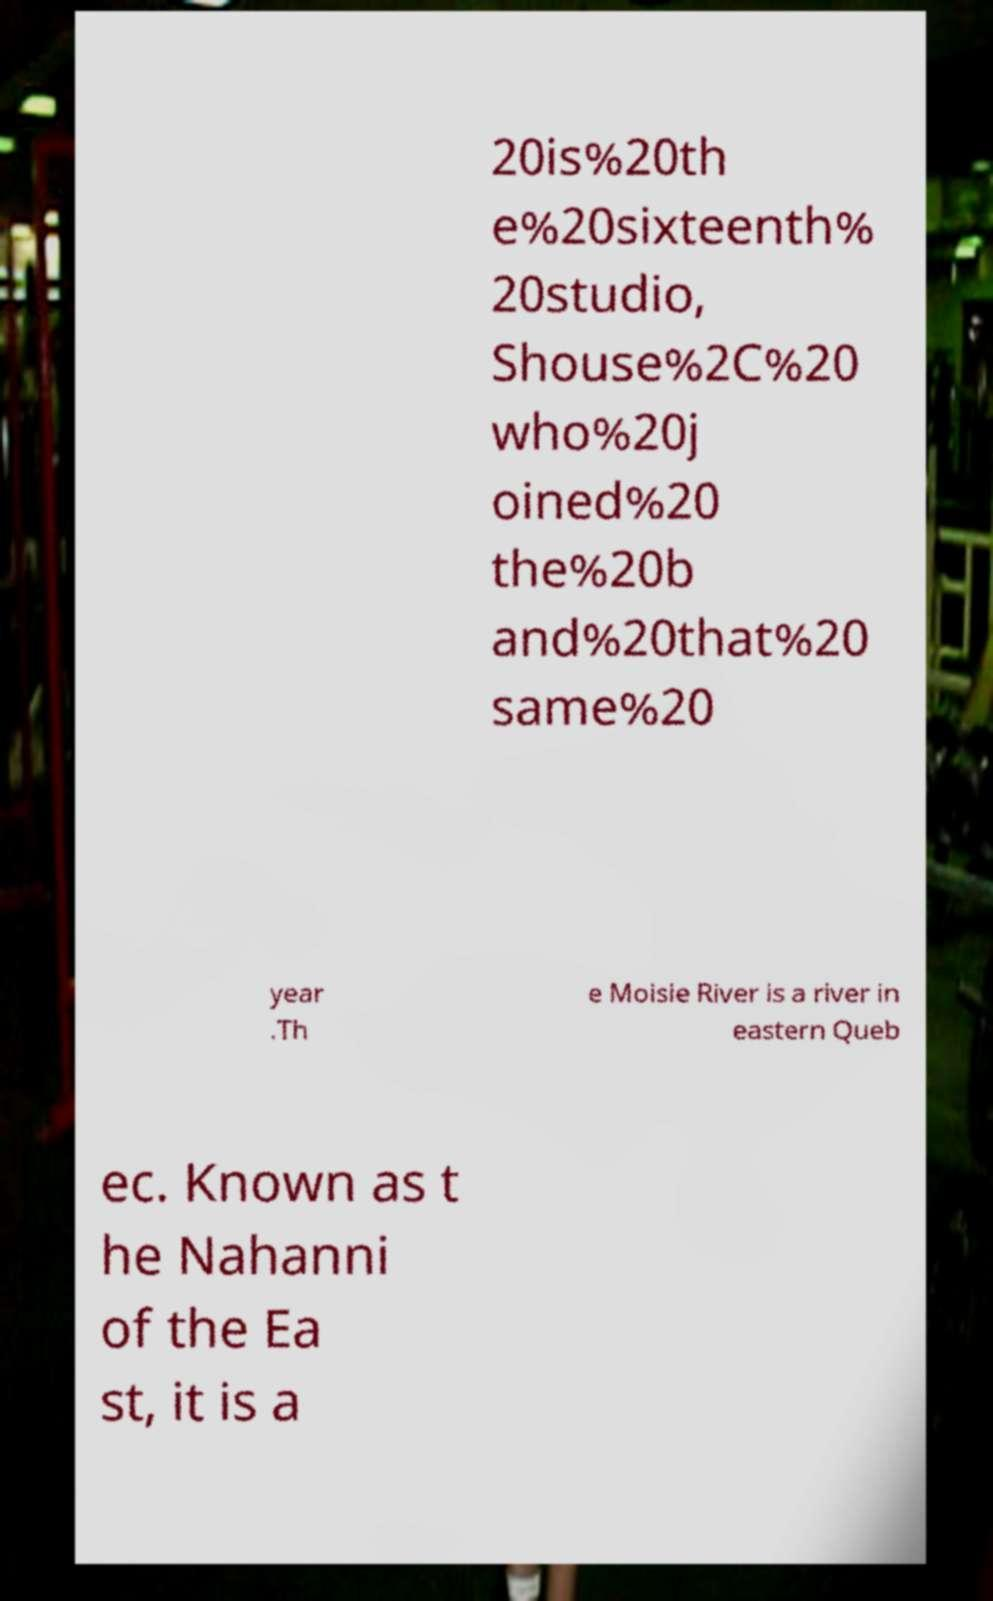For documentation purposes, I need the text within this image transcribed. Could you provide that? 20is%20th e%20sixteenth% 20studio, Shouse%2C%20 who%20j oined%20 the%20b and%20that%20 same%20 year .Th e Moisie River is a river in eastern Queb ec. Known as t he Nahanni of the Ea st, it is a 